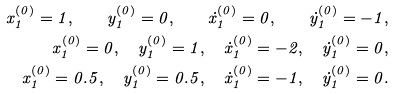Convert formula to latex. <formula><loc_0><loc_0><loc_500><loc_500>x _ { 1 } ^ { ( 0 ) } = 1 , \quad y _ { 1 } ^ { ( 0 ) } = 0 , \quad \dot { x } _ { 1 } ^ { ( 0 ) } = 0 , \quad \dot { y } _ { 1 } ^ { ( 0 ) } = - 1 , \\ x _ { 1 } ^ { ( 0 ) } = 0 , \quad y _ { 1 } ^ { ( 0 ) } = 1 , \quad \dot { x } _ { 1 } ^ { ( 0 ) } = - 2 , \quad \dot { y } _ { 1 } ^ { ( 0 ) } = 0 , \\ x _ { 1 } ^ { ( 0 ) } = 0 . 5 , \quad y _ { 1 } ^ { ( 0 ) } = 0 . 5 , \quad \dot { x } _ { 1 } ^ { ( 0 ) } = - 1 , \quad \dot { y } _ { 1 } ^ { ( 0 ) } = 0 .</formula> 